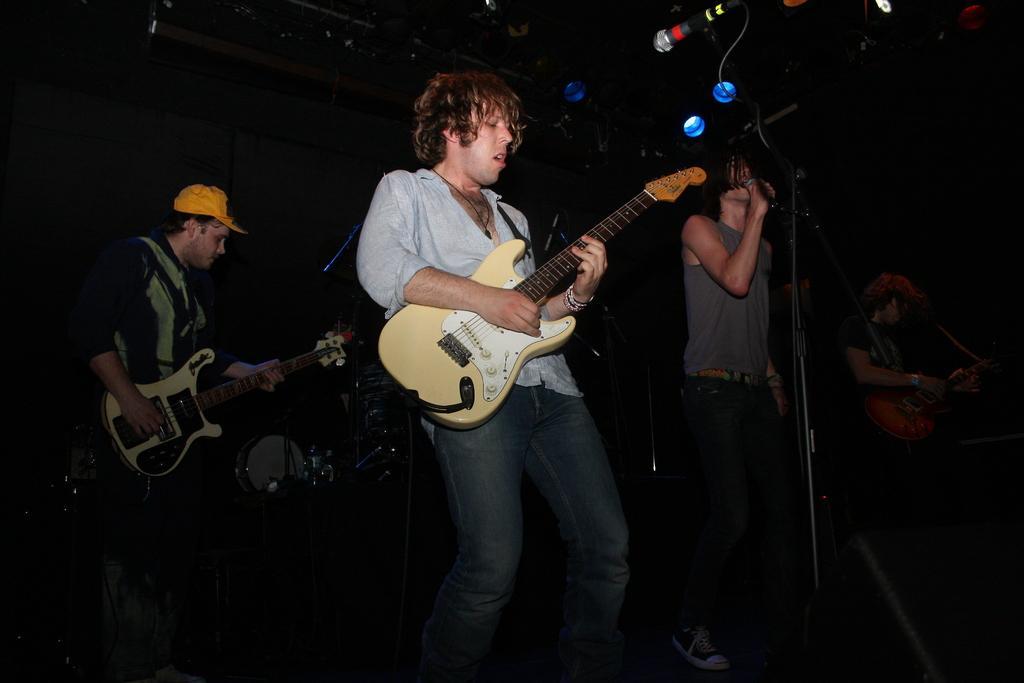Describe this image in one or two sentences. In this image I can see three people are standing and two of them are holding guitars. I can also see a mic. 